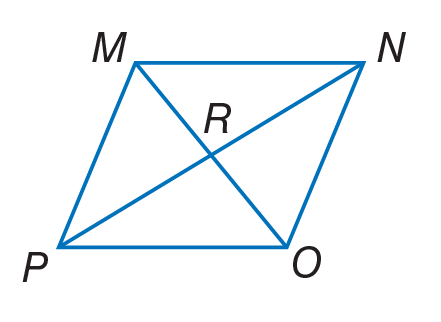Answer the mathemtical geometry problem and directly provide the correct option letter.
Question: Quadrilateral M N O P is a rhombus. If P R = 12, find R N.
Choices: A: 6 B: 12 C: 20 D: 24 B 